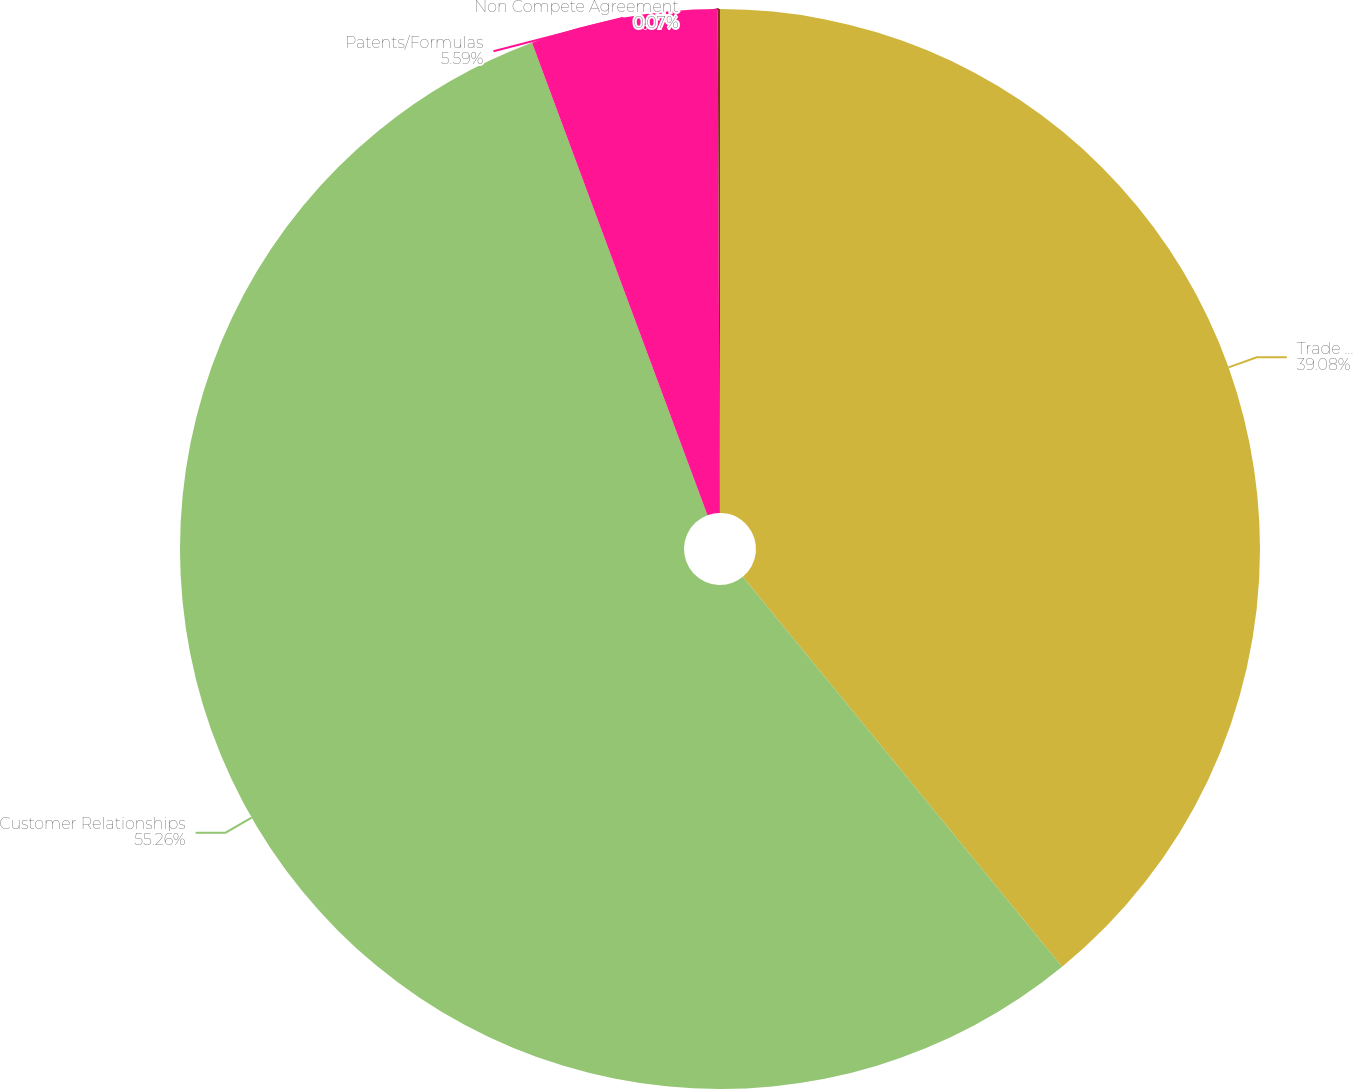Convert chart to OTSL. <chart><loc_0><loc_0><loc_500><loc_500><pie_chart><fcel>Trade names<fcel>Customer Relationships<fcel>Patents/Formulas<fcel>Non Compete Agreement<nl><fcel>39.08%<fcel>55.26%<fcel>5.59%<fcel>0.07%<nl></chart> 